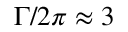Convert formula to latex. <formula><loc_0><loc_0><loc_500><loc_500>\Gamma / 2 \pi \approx 3</formula> 